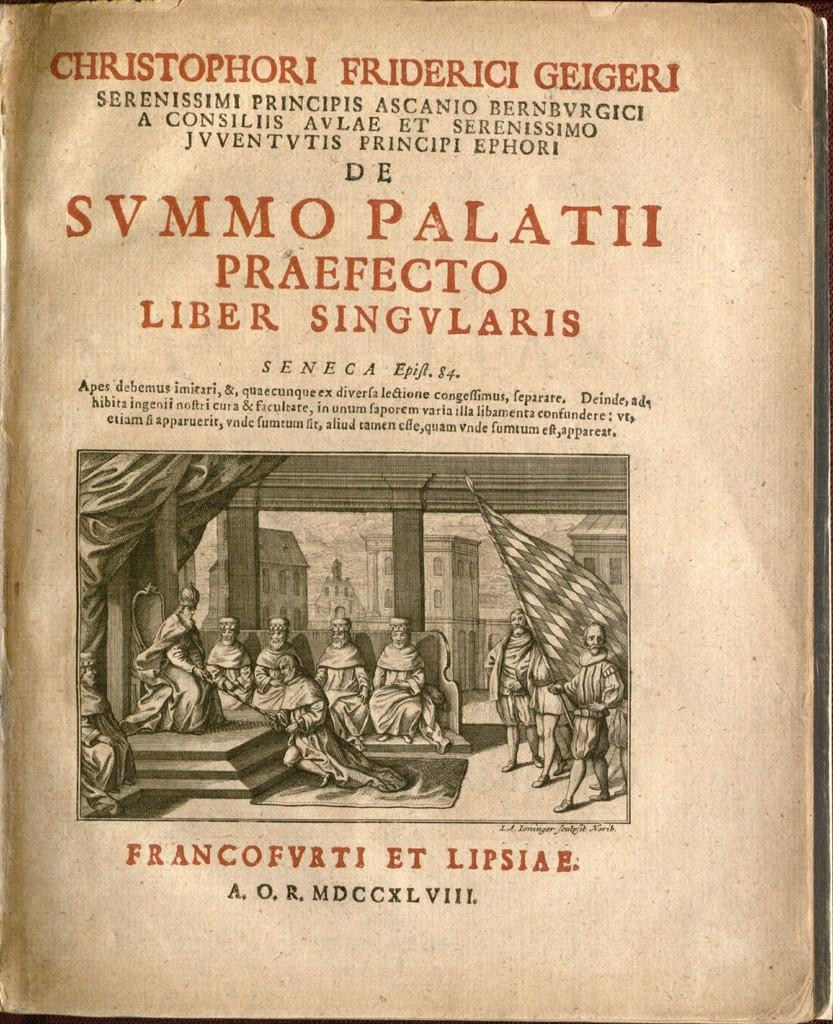Provide a one-sentence caption for the provided image. old book called svmmo palatti by frabcofvrti et. 